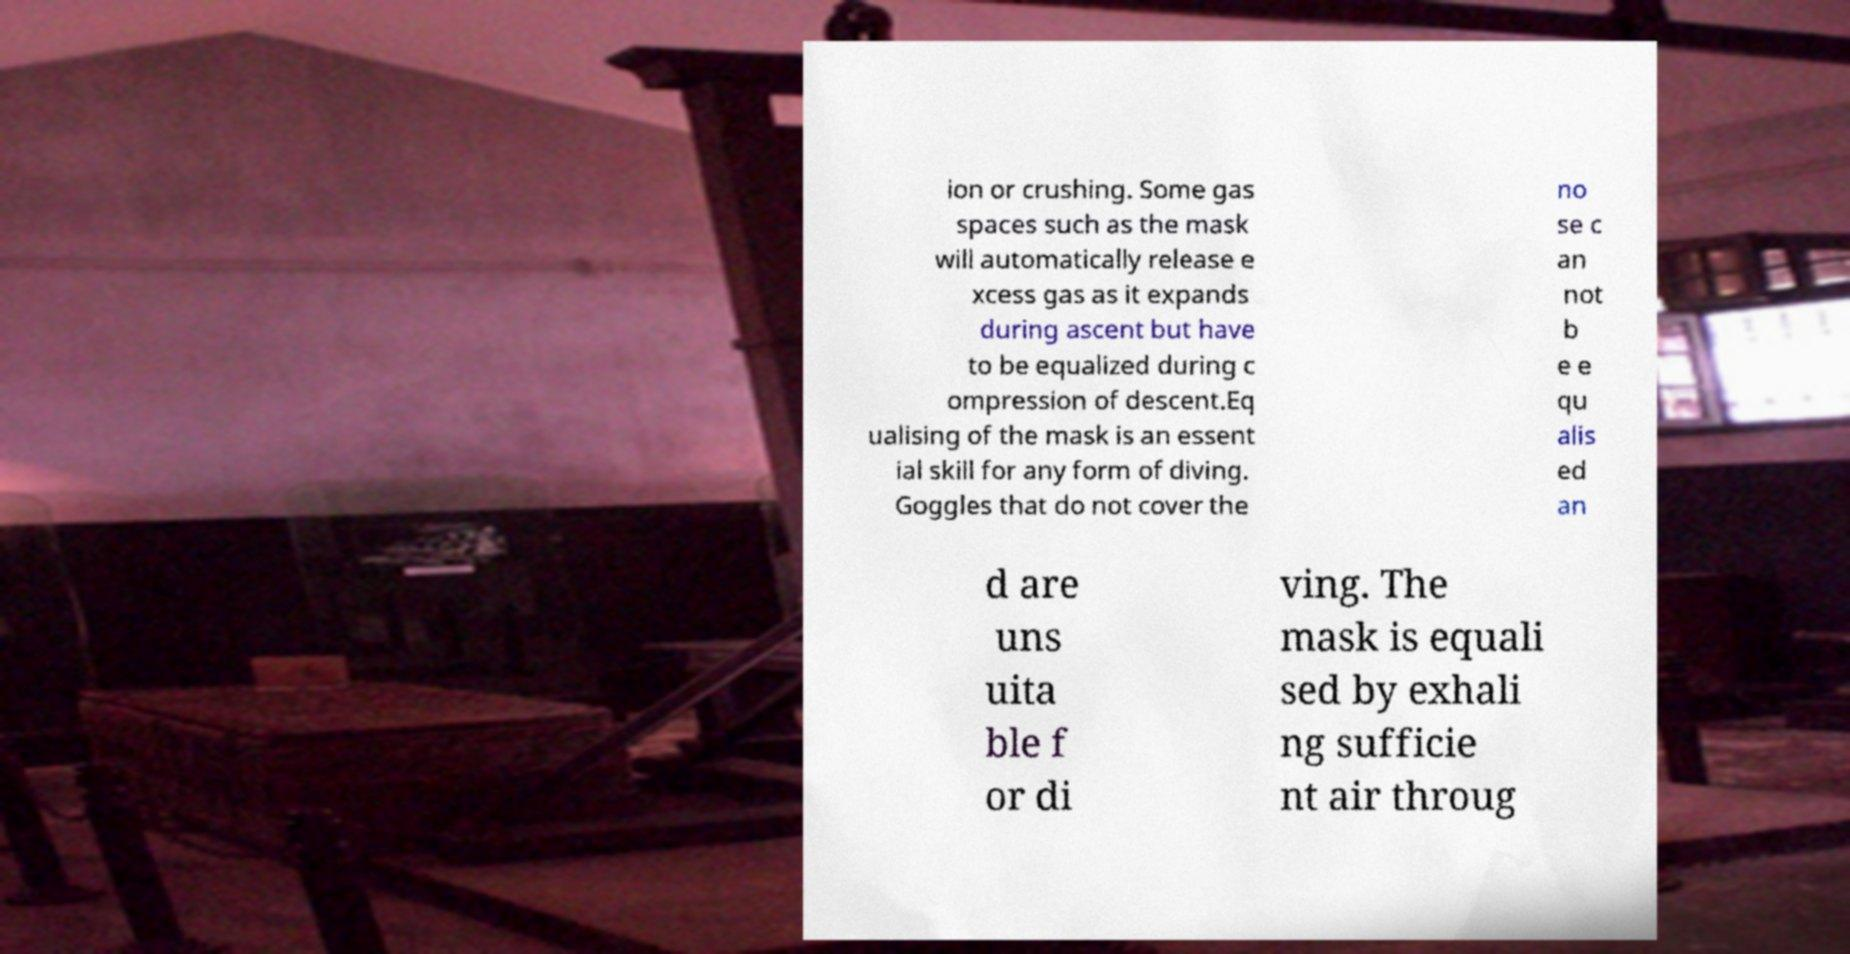I need the written content from this picture converted into text. Can you do that? ion or crushing. Some gas spaces such as the mask will automatically release e xcess gas as it expands during ascent but have to be equalized during c ompression of descent.Eq ualising of the mask is an essent ial skill for any form of diving. Goggles that do not cover the no se c an not b e e qu alis ed an d are uns uita ble f or di ving. The mask is equali sed by exhali ng sufficie nt air throug 